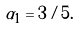Convert formula to latex. <formula><loc_0><loc_0><loc_500><loc_500>\alpha _ { 1 } = 3 / 5 .</formula> 